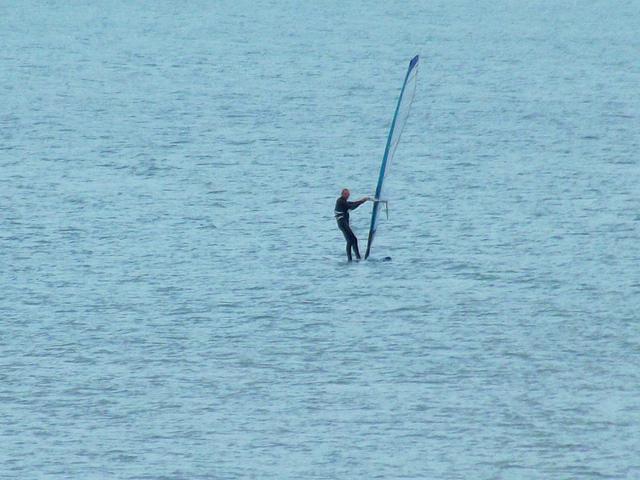What is this person riding?
Quick response, please. Wind board. Is the person wearing a wetsuit?
Concise answer only. Yes. What is this person doing?
Concise answer only. Windsurfing. What is the person standing on?
Concise answer only. Surfboard. 